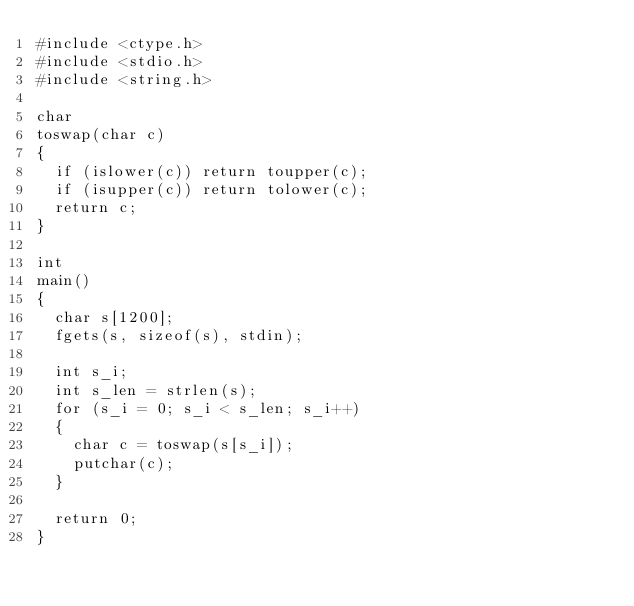<code> <loc_0><loc_0><loc_500><loc_500><_C_>#include <ctype.h>
#include <stdio.h>
#include <string.h>

char
toswap(char c)
{
	if (islower(c)) return toupper(c);
	if (isupper(c)) return tolower(c);
	return c;
}

int
main()
{
	char s[1200];
	fgets(s, sizeof(s), stdin);

	int s_i;
	int s_len = strlen(s);
	for (s_i = 0; s_i < s_len; s_i++)
	{
		char c = toswap(s[s_i]);
		putchar(c);
	}

	return 0;
}</code> 